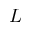Convert formula to latex. <formula><loc_0><loc_0><loc_500><loc_500>L</formula> 